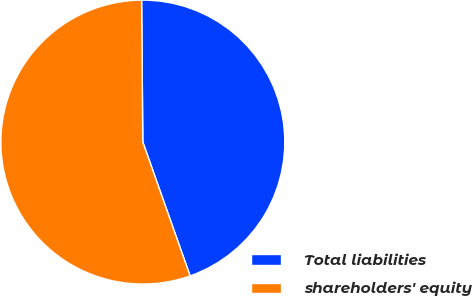Convert chart. <chart><loc_0><loc_0><loc_500><loc_500><pie_chart><fcel>Total liabilities<fcel>shareholders' equity<nl><fcel>44.73%<fcel>55.27%<nl></chart> 